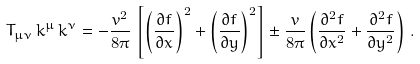Convert formula to latex. <formula><loc_0><loc_0><loc_500><loc_500>T _ { \mu \nu } \, k ^ { \mu } \, k ^ { \nu } = - \frac { v ^ { 2 } } { 8 \pi } \, \left [ \left ( \frac { \partial f } { \partial x } \right ) ^ { 2 } + \left ( \frac { \partial f } { \partial y } \right ) ^ { 2 } \right ] \pm \frac { v } { 8 \pi } \left ( \frac { \partial ^ { 2 } f } { \partial { x } ^ { 2 } } + \frac { \partial ^ { 2 } f } { \partial { y } ^ { 2 } } \right ) \, .</formula> 